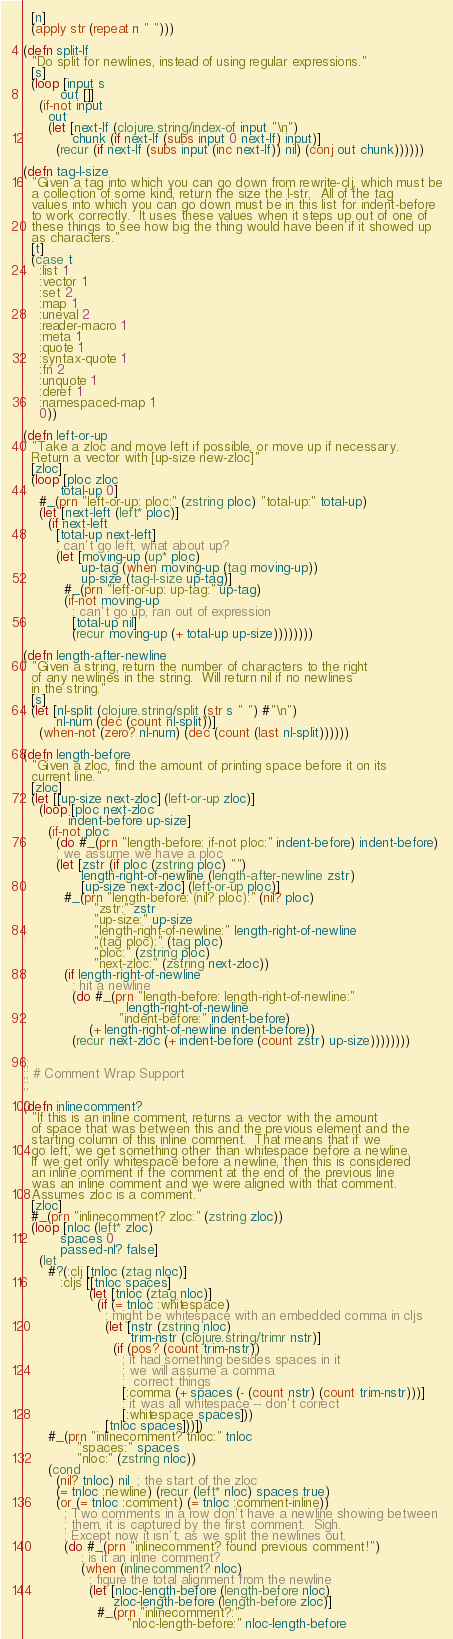<code> <loc_0><loc_0><loc_500><loc_500><_Clojure_>  [n]
  (apply str (repeat n " ")))

(defn split-lf
  "Do split for newlines, instead of using regular expressions."
  [s]
  (loop [input s
         out []]
    (if-not input
      out
      (let [next-lf (clojure.string/index-of input "\n")
            chunk (if next-lf (subs input 0 next-lf) input)]
        (recur (if next-lf (subs input (inc next-lf)) nil) (conj out chunk))))))

(defn tag-l-size
  "Given a tag into which you can go down from rewrite-clj, which must be
  a collection of some kind, return the size the l-str.  All of the tag
  values into which you can go down must be in this list for indent-before
  to work correctly.  It uses these values when it steps up out of one of
  these things to see how big the thing would have been if it showed up
  as characters."
  [t]
  (case t
    :list 1
    :vector 1
    :set 2
    :map 1
    :uneval 2
    :reader-macro 1
    :meta 1
    :quote 1
    :syntax-quote 1
    :fn 2
    :unquote 1
    :deref 1
    :namespaced-map 1
    0))

(defn left-or-up
  "Take a zloc and move left if possible, or move up if necessary.
  Return a vector with [up-size new-zloc]"
  [zloc]
  (loop [ploc zloc
         total-up 0]
    #_(prn "left-or-up: ploc:" (zstring ploc) "total-up:" total-up)
    (let [next-left (left* ploc)]
      (if next-left
        [total-up next-left]
        ; can't go left, what about up?
        (let [moving-up (up* ploc)
              up-tag (when moving-up (tag moving-up))
              up-size (tag-l-size up-tag)]
          #_(prn "left-or-up: up-tag:" up-tag)
          (if-not moving-up
            ; can't go up, ran out of expression
            [total-up nil]
            (recur moving-up (+ total-up up-size))))))))

(defn length-after-newline
  "Given a string, return the number of characters to the right
  of any newlines in the string.  Will return nil if no newlines
  in the string."
  [s]
  (let [nl-split (clojure.string/split (str s " ") #"\n")
        nl-num (dec (count nl-split))]
    (when-not (zero? nl-num) (dec (count (last nl-split))))))

(defn length-before
  "Given a zloc, find the amount of printing space before it on its
  current line."
  [zloc]
  (let [[up-size next-zloc] (left-or-up zloc)]
    (loop [ploc next-zloc
           indent-before up-size]
      (if-not ploc
        (do #_(prn "length-before: if-not ploc:" indent-before) indent-before)
        ; we assume we have a ploc
        (let [zstr (if ploc (zstring ploc) "")
              length-right-of-newline (length-after-newline zstr)
              [up-size next-zloc] (left-or-up ploc)]
          #_(prn "length-before: (nil? ploc):" (nil? ploc)
                 "zstr:" zstr
                 "up-size:" up-size
                 "length-right-of-newline:" length-right-of-newline
                 "(tag ploc):" (tag ploc)
                 "ploc:" (zstring ploc)
                 "next-zloc:" (zstring next-zloc))
          (if length-right-of-newline
            ; hit a newline
            (do #_(prn "length-before: length-right-of-newline:"
                         length-right-of-newline
                       "indent-before:" indent-before)
                (+ length-right-of-newline indent-before))
            (recur next-zloc (+ indent-before (count zstr) up-size))))))))

;;
;; # Comment Wrap Support
;;

(defn inlinecomment?
  "If this is an inline comment, returns a vector with the amount
  of space that was between this and the previous element and the
  starting column of this inline comment.  That means that if we
  go left, we get something other than whitespace before a newline.
  If we get only whitespace before a newline, then this is considered
  an inline comment if the comment at the end of the previous line
  was an inline comment and we were aligned with that comment.
  Assumes zloc is a comment."
  [zloc]
  #_(prn "inlinecomment? zloc:" (zstring zloc))
  (loop [nloc (left* zloc)
         spaces 0
         passed-nl? false]
    (let
      #?(:clj [tnloc (ztag nloc)]
         :cljs [[tnloc spaces]
                (let [tnloc (ztag nloc)]
                  (if (= tnloc :whitespace)
                    ; might be whitespace with an embedded comma in cljs
                    (let [nstr (zstring nloc)
                          trim-nstr (clojure.string/trimr nstr)]
                      (if (pos? (count trim-nstr))
                        ; it had something besides spaces in it
                        ; we will assume a comma
                        ;  correct things
                        [:comma (+ spaces (- (count nstr) (count trim-nstr)))]
                        ; it was all whitespace -- don't correct
                        [:whitespace spaces]))
                    [tnloc spaces]))])
      #_(prn "inlinecomment? tnloc:" tnloc
             "spaces:" spaces
             "nloc:" (zstring nloc))
      (cond
        (nil? tnloc) nil  ; the start of the zloc
        (= tnloc :newline) (recur (left* nloc) spaces true)
        (or (= tnloc :comment) (= tnloc :comment-inline))
          ; Two comments in a row don't have a newline showing between
          ; them, it is captured by the first comment.  Sigh.
          ; Except now it isn't, as we split the newlines out.
          (do #_(prn "inlinecomment? found previous comment!")
              ; is it an inline comment?
              (when (inlinecomment? nloc)
                ; figure the total alignment from the newline
                (let [nloc-length-before (length-before nloc)
                      zloc-length-before (length-before zloc)]
                  #_(prn "inlinecomment?:"
                         "nloc-length-before:" nloc-length-before</code> 